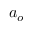<formula> <loc_0><loc_0><loc_500><loc_500>a _ { o }</formula> 